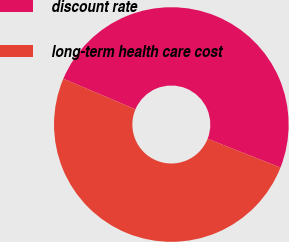Convert chart to OTSL. <chart><loc_0><loc_0><loc_500><loc_500><pie_chart><fcel>discount rate<fcel>long-term health care cost<nl><fcel>49.59%<fcel>50.41%<nl></chart> 